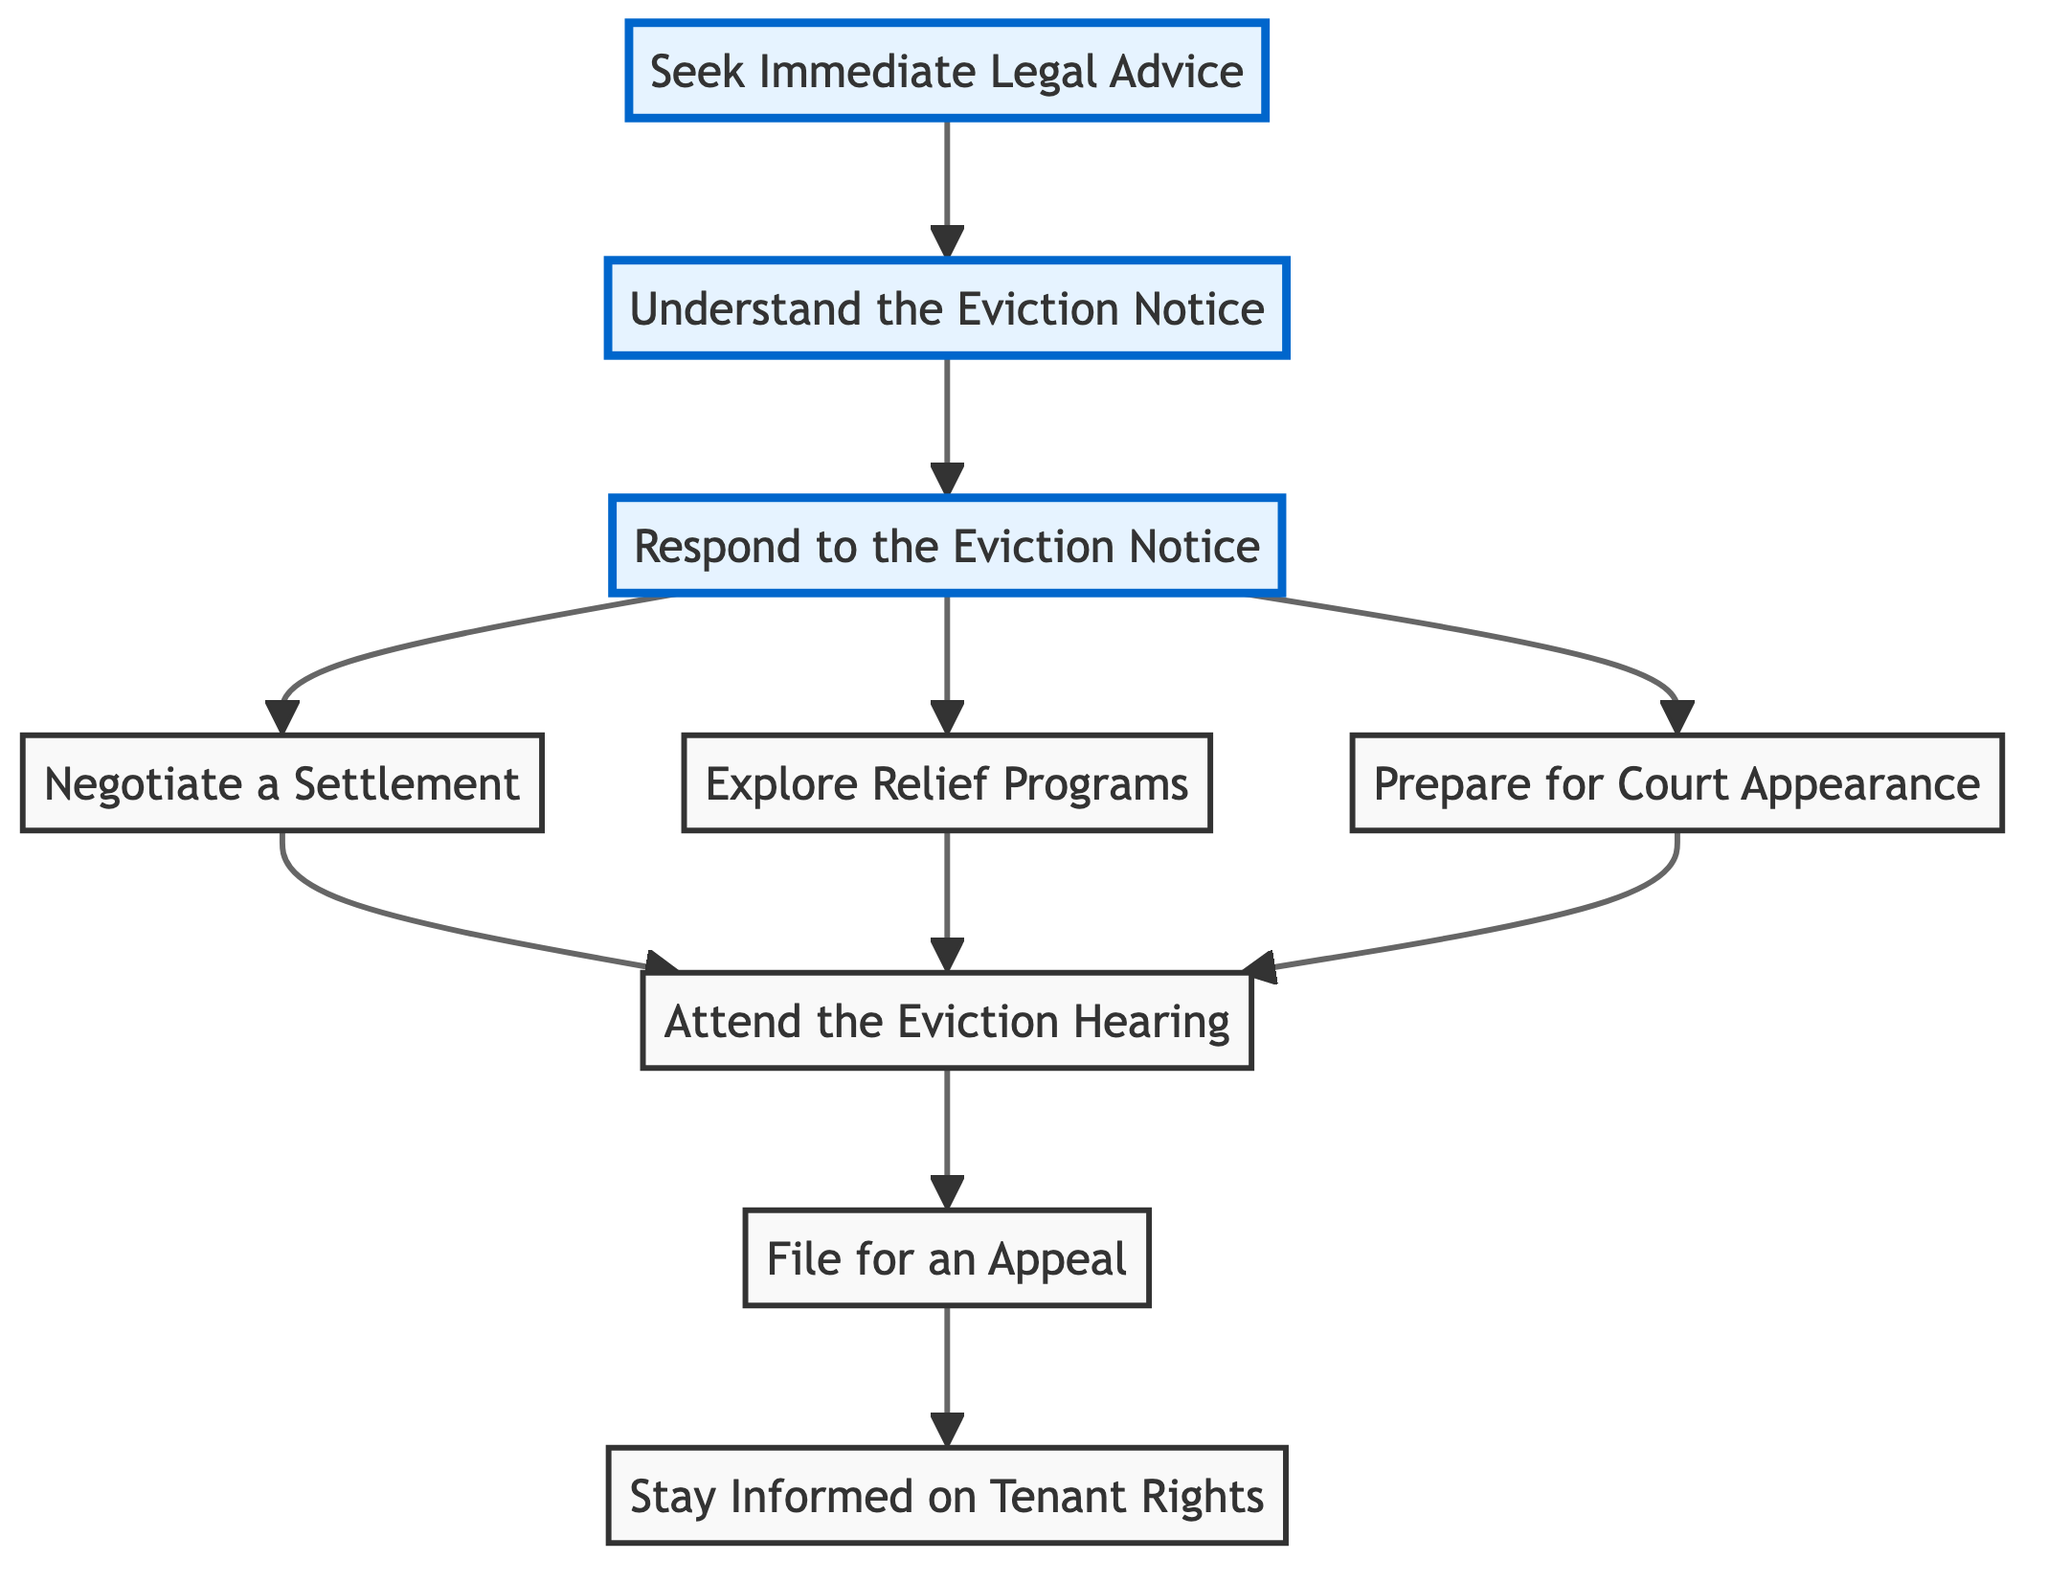What is the first step in the eviction process according to the diagram? The first step in the eviction process is "Seek Immediate Legal Advice," which is the initial node at the bottom of the diagram.
Answer: Seek Immediate Legal Advice How many nodes are present in the diagram? The diagram contains a total of ten nodes, including the final step "Stay Informed on Tenant Rights."
Answer: Ten Which step follows after "Negotiate a Settlement" in the flowchart? "Attend the Eviction Hearing" follows after "Negotiate a Settlement," as indicated by the arrow leading from F to C.
Answer: Attend the Eviction Hearing What is the last step in the flowchart? The last step in the flowchart is "Stay Informed on Tenant Rights," which is the final node at the top of the diagram.
Answer: Stay Informed on Tenant Rights What is the relationship between "Understand the Eviction Notice" and "Respond to the Eviction Notice"? "Understand the Eviction Notice" directly precedes "Respond to the Eviction Notice," showing that understanding the notice is necessary before responding to it, as indicated by the arrow from H to G.
Answer: Precedes How do you get to "File for an Appeal"? To get to "File for an Appeal," you first need to attend the eviction hearing, and if the court rules in favor of the landlord, you then understand the process to file for an appeal, as indicated by the flow from C to B.
Answer: Attend the Eviction Hearing What are two possible actions you can take after receiving an eviction notice? After receiving an eviction notice, you can either "Negotiate a Settlement" or "Explore Relief Programs," which are two branches stemming from "Respond to the Eviction Notice."
Answer: Negotiate a Settlement, Explore Relief Programs Which node emphasizes the importance of legal aid? The node "Seek Immediate Legal Advice" emphasizes the importance of legal aid as it is the first action recommended in the flowchart.
Answer: Seek Immediate Legal Advice What sequence of steps would you follow if you're facing eviction? The sequence is: "Seek Immediate Legal Advice," "Understand the Eviction Notice," "Respond to the Eviction Notice," and then either "Negotiate a Settlement" or "Explore Relief Programs," leading to "Prepare for Court Appearance."
Answer: Seek Immediate Legal Advice, Understand the Eviction Notice, Respond to the Eviction Notice, Negotiate a Settlement/Explore Relief Programs, Prepare for Court Appearance 